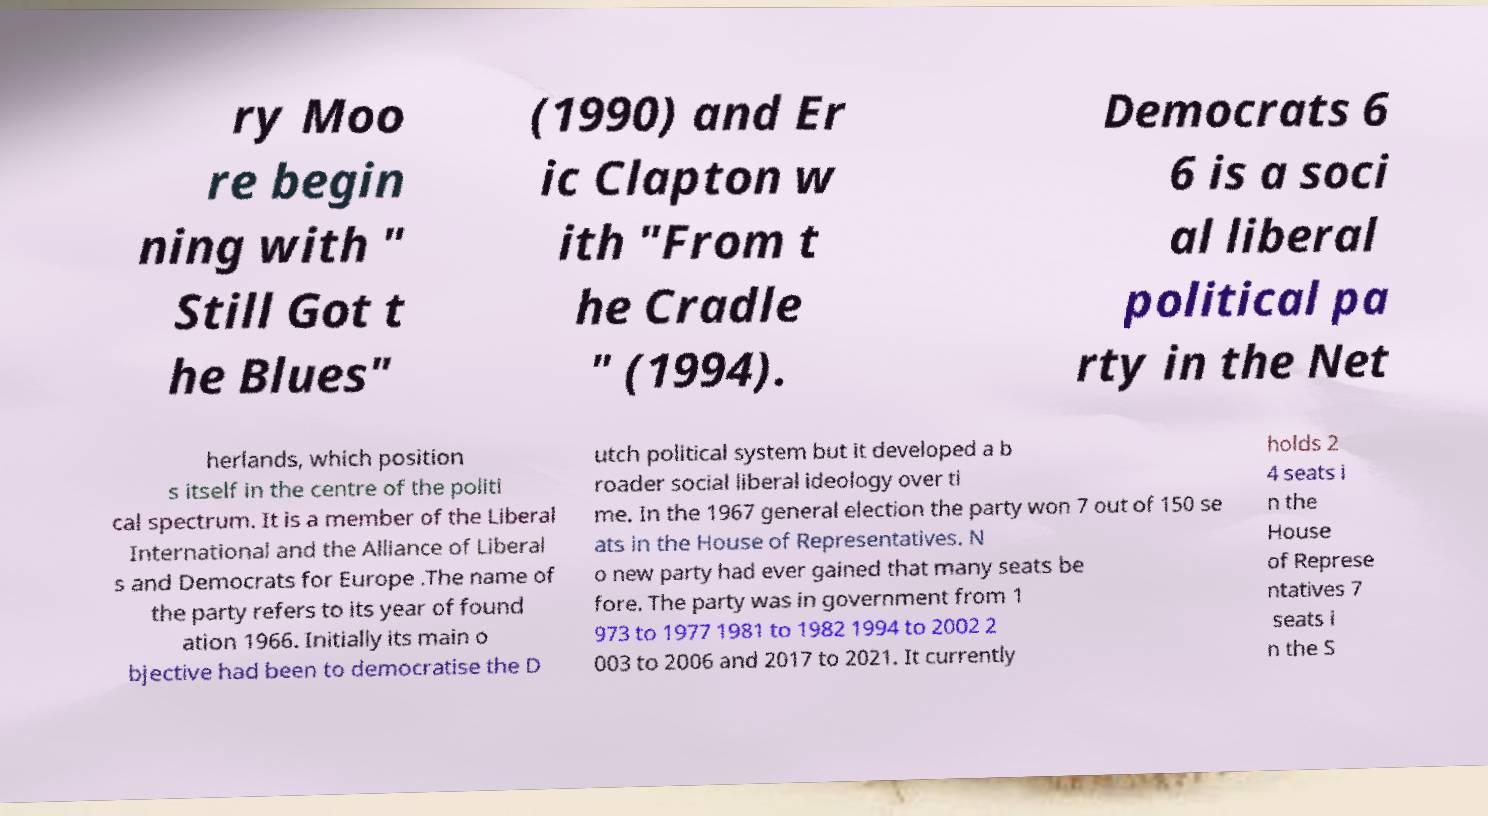Can you read and provide the text displayed in the image?This photo seems to have some interesting text. Can you extract and type it out for me? ry Moo re begin ning with " Still Got t he Blues" (1990) and Er ic Clapton w ith "From t he Cradle " (1994). Democrats 6 6 is a soci al liberal political pa rty in the Net herlands, which position s itself in the centre of the politi cal spectrum. It is a member of the Liberal International and the Alliance of Liberal s and Democrats for Europe .The name of the party refers to its year of found ation 1966. Initially its main o bjective had been to democratise the D utch political system but it developed a b roader social liberal ideology over ti me. In the 1967 general election the party won 7 out of 150 se ats in the House of Representatives. N o new party had ever gained that many seats be fore. The party was in government from 1 973 to 1977 1981 to 1982 1994 to 2002 2 003 to 2006 and 2017 to 2021. It currently holds 2 4 seats i n the House of Represe ntatives 7 seats i n the S 